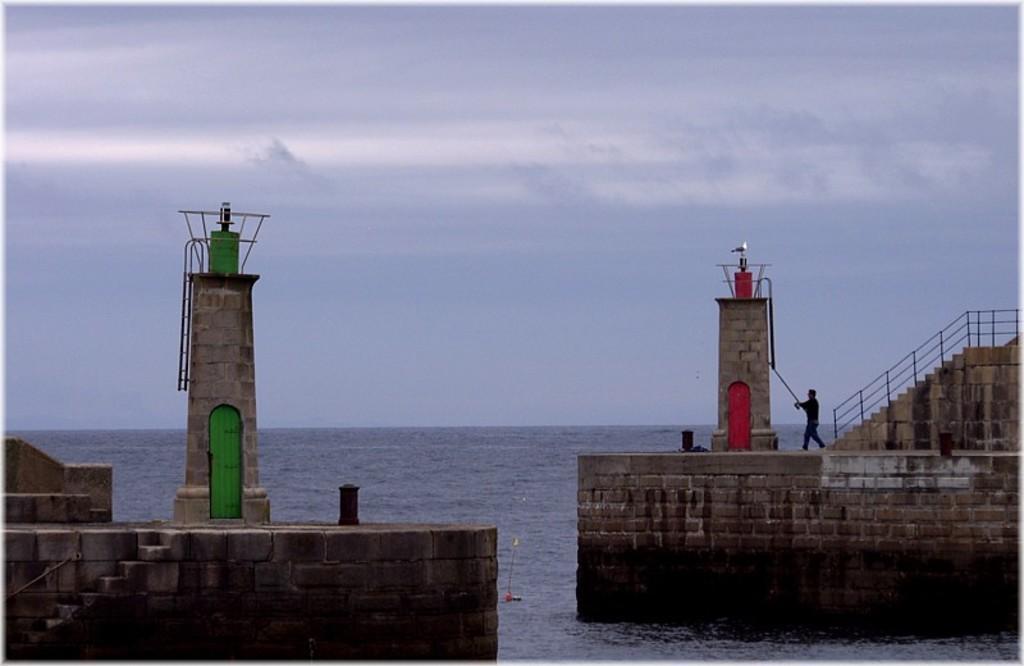How would you summarize this image in a sentence or two? In this image we can see a cloudy sky, water, lighthouses, walls, railing, person and steps.  